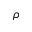Convert formula to latex. <formula><loc_0><loc_0><loc_500><loc_500>\rho</formula> 